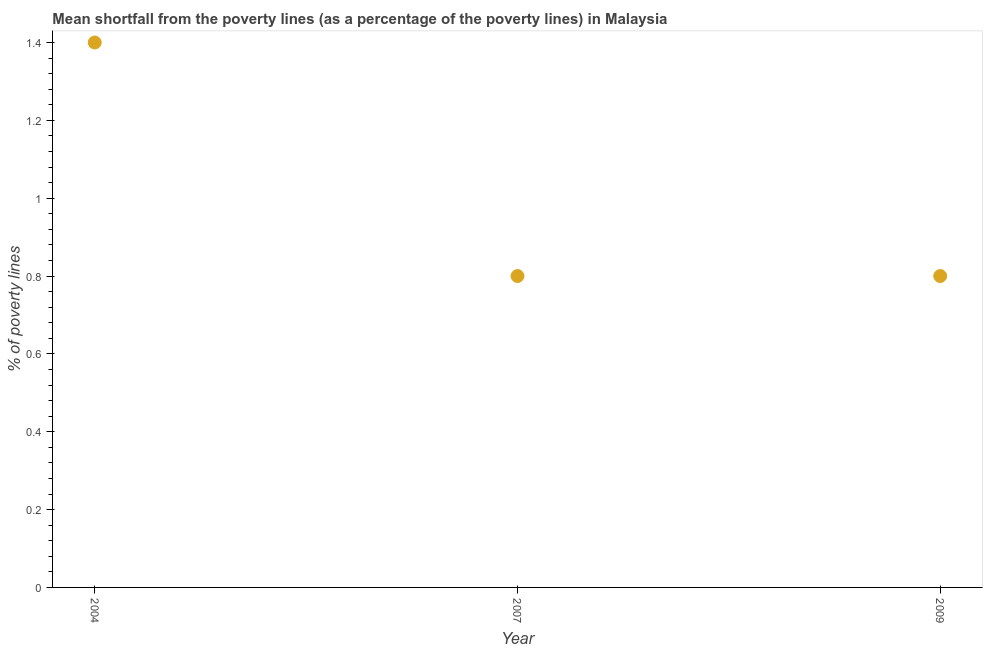Across all years, what is the minimum poverty gap at national poverty lines?
Give a very brief answer. 0.8. In which year was the poverty gap at national poverty lines minimum?
Keep it short and to the point. 2007. What is the sum of the poverty gap at national poverty lines?
Ensure brevity in your answer.  3. What is the median poverty gap at national poverty lines?
Provide a short and direct response. 0.8. Do a majority of the years between 2009 and 2004 (inclusive) have poverty gap at national poverty lines greater than 1.3200000000000003 %?
Give a very brief answer. No. What is the ratio of the poverty gap at national poverty lines in 2004 to that in 2009?
Make the answer very short. 1.75. Is the poverty gap at national poverty lines in 2004 less than that in 2007?
Keep it short and to the point. No. What is the difference between the highest and the second highest poverty gap at national poverty lines?
Keep it short and to the point. 0.6. Is the sum of the poverty gap at national poverty lines in 2004 and 2007 greater than the maximum poverty gap at national poverty lines across all years?
Make the answer very short. Yes. What is the difference between the highest and the lowest poverty gap at national poverty lines?
Your answer should be compact. 0.6. Does the poverty gap at national poverty lines monotonically increase over the years?
Your answer should be very brief. No. How many years are there in the graph?
Your answer should be compact. 3. What is the difference between two consecutive major ticks on the Y-axis?
Ensure brevity in your answer.  0.2. Does the graph contain grids?
Your response must be concise. No. What is the title of the graph?
Offer a terse response. Mean shortfall from the poverty lines (as a percentage of the poverty lines) in Malaysia. What is the label or title of the Y-axis?
Provide a short and direct response. % of poverty lines. What is the % of poverty lines in 2004?
Provide a short and direct response. 1.4. What is the % of poverty lines in 2007?
Your response must be concise. 0.8. What is the difference between the % of poverty lines in 2004 and 2009?
Your answer should be compact. 0.6. What is the difference between the % of poverty lines in 2007 and 2009?
Your answer should be compact. 0. What is the ratio of the % of poverty lines in 2004 to that in 2009?
Provide a succinct answer. 1.75. What is the ratio of the % of poverty lines in 2007 to that in 2009?
Offer a very short reply. 1. 